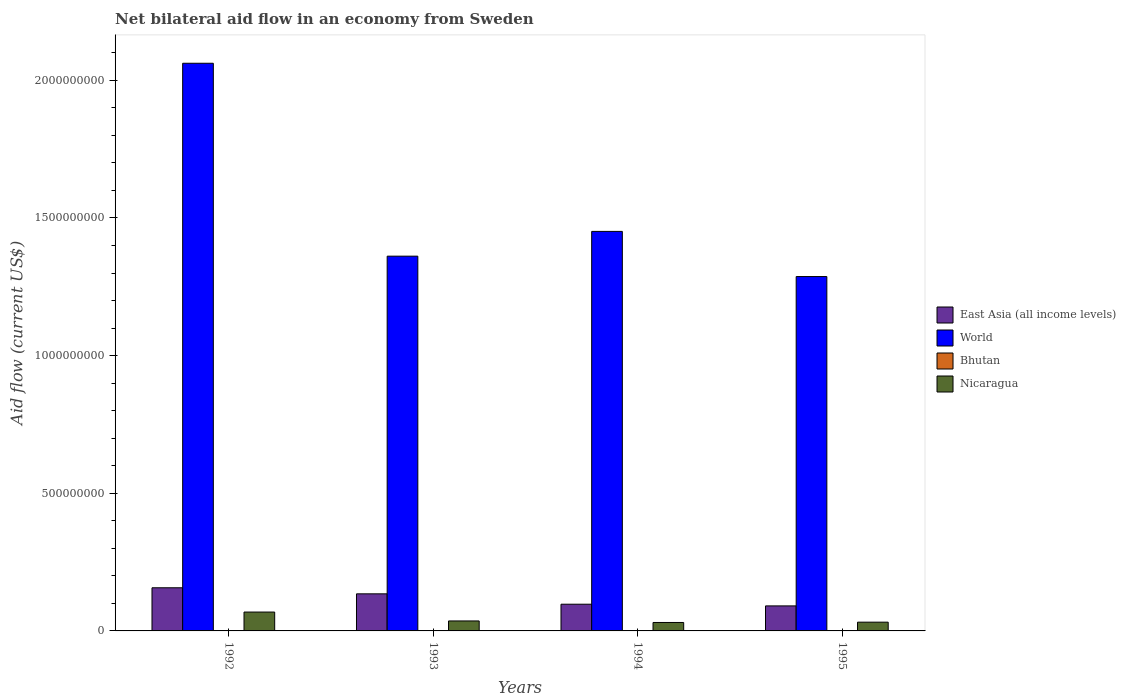How many different coloured bars are there?
Your response must be concise. 4. How many bars are there on the 4th tick from the right?
Keep it short and to the point. 4. What is the label of the 4th group of bars from the left?
Offer a terse response. 1995. In how many cases, is the number of bars for a given year not equal to the number of legend labels?
Offer a terse response. 0. What is the net bilateral aid flow in World in 1993?
Ensure brevity in your answer.  1.36e+09. Across all years, what is the maximum net bilateral aid flow in World?
Make the answer very short. 2.06e+09. Across all years, what is the minimum net bilateral aid flow in East Asia (all income levels)?
Ensure brevity in your answer.  9.09e+07. In which year was the net bilateral aid flow in Bhutan maximum?
Provide a short and direct response. 1995. What is the total net bilateral aid flow in Nicaragua in the graph?
Offer a very short reply. 1.67e+08. What is the difference between the net bilateral aid flow in Nicaragua in 1992 and that in 1994?
Keep it short and to the point. 3.79e+07. What is the difference between the net bilateral aid flow in World in 1994 and the net bilateral aid flow in Nicaragua in 1995?
Keep it short and to the point. 1.42e+09. What is the average net bilateral aid flow in Nicaragua per year?
Make the answer very short. 4.18e+07. In the year 1995, what is the difference between the net bilateral aid flow in Nicaragua and net bilateral aid flow in East Asia (all income levels)?
Give a very brief answer. -5.91e+07. In how many years, is the net bilateral aid flow in World greater than 200000000 US$?
Your response must be concise. 4. What is the ratio of the net bilateral aid flow in World in 1993 to that in 1994?
Provide a succinct answer. 0.94. Is the net bilateral aid flow in Bhutan in 1993 less than that in 1994?
Your response must be concise. Yes. Is the difference between the net bilateral aid flow in Nicaragua in 1993 and 1994 greater than the difference between the net bilateral aid flow in East Asia (all income levels) in 1993 and 1994?
Provide a short and direct response. No. What is the difference between the highest and the second highest net bilateral aid flow in World?
Your answer should be compact. 6.11e+08. Is the sum of the net bilateral aid flow in East Asia (all income levels) in 1993 and 1994 greater than the maximum net bilateral aid flow in Bhutan across all years?
Your response must be concise. Yes. What does the 3rd bar from the left in 1995 represents?
Offer a very short reply. Bhutan. Is it the case that in every year, the sum of the net bilateral aid flow in Nicaragua and net bilateral aid flow in East Asia (all income levels) is greater than the net bilateral aid flow in World?
Provide a succinct answer. No. How many years are there in the graph?
Keep it short and to the point. 4. What is the difference between two consecutive major ticks on the Y-axis?
Your answer should be compact. 5.00e+08. Are the values on the major ticks of Y-axis written in scientific E-notation?
Ensure brevity in your answer.  No. Does the graph contain any zero values?
Your answer should be very brief. No. Does the graph contain grids?
Keep it short and to the point. No. How many legend labels are there?
Your answer should be very brief. 4. What is the title of the graph?
Your answer should be compact. Net bilateral aid flow in an economy from Sweden. Does "Tunisia" appear as one of the legend labels in the graph?
Your response must be concise. No. What is the label or title of the X-axis?
Ensure brevity in your answer.  Years. What is the label or title of the Y-axis?
Provide a short and direct response. Aid flow (current US$). What is the Aid flow (current US$) of East Asia (all income levels) in 1992?
Ensure brevity in your answer.  1.57e+08. What is the Aid flow (current US$) in World in 1992?
Your answer should be compact. 2.06e+09. What is the Aid flow (current US$) in Nicaragua in 1992?
Your answer should be compact. 6.85e+07. What is the Aid flow (current US$) in East Asia (all income levels) in 1993?
Provide a short and direct response. 1.35e+08. What is the Aid flow (current US$) in World in 1993?
Offer a terse response. 1.36e+09. What is the Aid flow (current US$) in Bhutan in 1993?
Offer a terse response. 1.90e+05. What is the Aid flow (current US$) of Nicaragua in 1993?
Your response must be concise. 3.63e+07. What is the Aid flow (current US$) of East Asia (all income levels) in 1994?
Make the answer very short. 9.70e+07. What is the Aid flow (current US$) in World in 1994?
Provide a succinct answer. 1.45e+09. What is the Aid flow (current US$) in Nicaragua in 1994?
Ensure brevity in your answer.  3.07e+07. What is the Aid flow (current US$) of East Asia (all income levels) in 1995?
Provide a succinct answer. 9.09e+07. What is the Aid flow (current US$) of World in 1995?
Ensure brevity in your answer.  1.29e+09. What is the Aid flow (current US$) in Bhutan in 1995?
Provide a succinct answer. 4.80e+05. What is the Aid flow (current US$) in Nicaragua in 1995?
Keep it short and to the point. 3.18e+07. Across all years, what is the maximum Aid flow (current US$) in East Asia (all income levels)?
Provide a short and direct response. 1.57e+08. Across all years, what is the maximum Aid flow (current US$) of World?
Provide a succinct answer. 2.06e+09. Across all years, what is the maximum Aid flow (current US$) of Bhutan?
Offer a terse response. 4.80e+05. Across all years, what is the maximum Aid flow (current US$) of Nicaragua?
Your answer should be very brief. 6.85e+07. Across all years, what is the minimum Aid flow (current US$) of East Asia (all income levels)?
Offer a terse response. 9.09e+07. Across all years, what is the minimum Aid flow (current US$) of World?
Provide a short and direct response. 1.29e+09. Across all years, what is the minimum Aid flow (current US$) in Bhutan?
Give a very brief answer. 1.90e+05. Across all years, what is the minimum Aid flow (current US$) of Nicaragua?
Your answer should be compact. 3.07e+07. What is the total Aid flow (current US$) in East Asia (all income levels) in the graph?
Make the answer very short. 4.79e+08. What is the total Aid flow (current US$) in World in the graph?
Keep it short and to the point. 6.16e+09. What is the total Aid flow (current US$) of Bhutan in the graph?
Your answer should be very brief. 1.30e+06. What is the total Aid flow (current US$) in Nicaragua in the graph?
Give a very brief answer. 1.67e+08. What is the difference between the Aid flow (current US$) of East Asia (all income levels) in 1992 and that in 1993?
Your answer should be very brief. 2.20e+07. What is the difference between the Aid flow (current US$) in World in 1992 and that in 1993?
Give a very brief answer. 7.01e+08. What is the difference between the Aid flow (current US$) of Nicaragua in 1992 and that in 1993?
Provide a short and direct response. 3.23e+07. What is the difference between the Aid flow (current US$) in East Asia (all income levels) in 1992 and that in 1994?
Keep it short and to the point. 5.97e+07. What is the difference between the Aid flow (current US$) of World in 1992 and that in 1994?
Ensure brevity in your answer.  6.11e+08. What is the difference between the Aid flow (current US$) in Nicaragua in 1992 and that in 1994?
Ensure brevity in your answer.  3.79e+07. What is the difference between the Aid flow (current US$) in East Asia (all income levels) in 1992 and that in 1995?
Your answer should be compact. 6.58e+07. What is the difference between the Aid flow (current US$) of World in 1992 and that in 1995?
Make the answer very short. 7.75e+08. What is the difference between the Aid flow (current US$) in Bhutan in 1992 and that in 1995?
Make the answer very short. -1.30e+05. What is the difference between the Aid flow (current US$) of Nicaragua in 1992 and that in 1995?
Offer a terse response. 3.67e+07. What is the difference between the Aid flow (current US$) in East Asia (all income levels) in 1993 and that in 1994?
Ensure brevity in your answer.  3.77e+07. What is the difference between the Aid flow (current US$) of World in 1993 and that in 1994?
Offer a terse response. -9.00e+07. What is the difference between the Aid flow (current US$) of Nicaragua in 1993 and that in 1994?
Give a very brief answer. 5.60e+06. What is the difference between the Aid flow (current US$) in East Asia (all income levels) in 1993 and that in 1995?
Your response must be concise. 4.38e+07. What is the difference between the Aid flow (current US$) in World in 1993 and that in 1995?
Your answer should be very brief. 7.41e+07. What is the difference between the Aid flow (current US$) in Nicaragua in 1993 and that in 1995?
Offer a very short reply. 4.44e+06. What is the difference between the Aid flow (current US$) of East Asia (all income levels) in 1994 and that in 1995?
Offer a very short reply. 6.15e+06. What is the difference between the Aid flow (current US$) of World in 1994 and that in 1995?
Offer a very short reply. 1.64e+08. What is the difference between the Aid flow (current US$) in Bhutan in 1994 and that in 1995?
Your answer should be very brief. -2.00e+05. What is the difference between the Aid flow (current US$) in Nicaragua in 1994 and that in 1995?
Ensure brevity in your answer.  -1.16e+06. What is the difference between the Aid flow (current US$) of East Asia (all income levels) in 1992 and the Aid flow (current US$) of World in 1993?
Ensure brevity in your answer.  -1.20e+09. What is the difference between the Aid flow (current US$) of East Asia (all income levels) in 1992 and the Aid flow (current US$) of Bhutan in 1993?
Ensure brevity in your answer.  1.57e+08. What is the difference between the Aid flow (current US$) of East Asia (all income levels) in 1992 and the Aid flow (current US$) of Nicaragua in 1993?
Provide a short and direct response. 1.20e+08. What is the difference between the Aid flow (current US$) in World in 1992 and the Aid flow (current US$) in Bhutan in 1993?
Give a very brief answer. 2.06e+09. What is the difference between the Aid flow (current US$) in World in 1992 and the Aid flow (current US$) in Nicaragua in 1993?
Offer a terse response. 2.03e+09. What is the difference between the Aid flow (current US$) in Bhutan in 1992 and the Aid flow (current US$) in Nicaragua in 1993?
Offer a very short reply. -3.59e+07. What is the difference between the Aid flow (current US$) in East Asia (all income levels) in 1992 and the Aid flow (current US$) in World in 1994?
Offer a very short reply. -1.29e+09. What is the difference between the Aid flow (current US$) of East Asia (all income levels) in 1992 and the Aid flow (current US$) of Bhutan in 1994?
Ensure brevity in your answer.  1.56e+08. What is the difference between the Aid flow (current US$) of East Asia (all income levels) in 1992 and the Aid flow (current US$) of Nicaragua in 1994?
Provide a succinct answer. 1.26e+08. What is the difference between the Aid flow (current US$) in World in 1992 and the Aid flow (current US$) in Bhutan in 1994?
Offer a very short reply. 2.06e+09. What is the difference between the Aid flow (current US$) in World in 1992 and the Aid flow (current US$) in Nicaragua in 1994?
Make the answer very short. 2.03e+09. What is the difference between the Aid flow (current US$) in Bhutan in 1992 and the Aid flow (current US$) in Nicaragua in 1994?
Keep it short and to the point. -3.03e+07. What is the difference between the Aid flow (current US$) of East Asia (all income levels) in 1992 and the Aid flow (current US$) of World in 1995?
Give a very brief answer. -1.13e+09. What is the difference between the Aid flow (current US$) in East Asia (all income levels) in 1992 and the Aid flow (current US$) in Bhutan in 1995?
Your answer should be very brief. 1.56e+08. What is the difference between the Aid flow (current US$) of East Asia (all income levels) in 1992 and the Aid flow (current US$) of Nicaragua in 1995?
Keep it short and to the point. 1.25e+08. What is the difference between the Aid flow (current US$) in World in 1992 and the Aid flow (current US$) in Bhutan in 1995?
Ensure brevity in your answer.  2.06e+09. What is the difference between the Aid flow (current US$) in World in 1992 and the Aid flow (current US$) in Nicaragua in 1995?
Keep it short and to the point. 2.03e+09. What is the difference between the Aid flow (current US$) of Bhutan in 1992 and the Aid flow (current US$) of Nicaragua in 1995?
Keep it short and to the point. -3.15e+07. What is the difference between the Aid flow (current US$) in East Asia (all income levels) in 1993 and the Aid flow (current US$) in World in 1994?
Keep it short and to the point. -1.32e+09. What is the difference between the Aid flow (current US$) of East Asia (all income levels) in 1993 and the Aid flow (current US$) of Bhutan in 1994?
Keep it short and to the point. 1.34e+08. What is the difference between the Aid flow (current US$) in East Asia (all income levels) in 1993 and the Aid flow (current US$) in Nicaragua in 1994?
Give a very brief answer. 1.04e+08. What is the difference between the Aid flow (current US$) of World in 1993 and the Aid flow (current US$) of Bhutan in 1994?
Offer a very short reply. 1.36e+09. What is the difference between the Aid flow (current US$) in World in 1993 and the Aid flow (current US$) in Nicaragua in 1994?
Offer a terse response. 1.33e+09. What is the difference between the Aid flow (current US$) of Bhutan in 1993 and the Aid flow (current US$) of Nicaragua in 1994?
Give a very brief answer. -3.05e+07. What is the difference between the Aid flow (current US$) in East Asia (all income levels) in 1993 and the Aid flow (current US$) in World in 1995?
Your answer should be compact. -1.15e+09. What is the difference between the Aid flow (current US$) of East Asia (all income levels) in 1993 and the Aid flow (current US$) of Bhutan in 1995?
Offer a very short reply. 1.34e+08. What is the difference between the Aid flow (current US$) of East Asia (all income levels) in 1993 and the Aid flow (current US$) of Nicaragua in 1995?
Your answer should be compact. 1.03e+08. What is the difference between the Aid flow (current US$) in World in 1993 and the Aid flow (current US$) in Bhutan in 1995?
Your response must be concise. 1.36e+09. What is the difference between the Aid flow (current US$) in World in 1993 and the Aid flow (current US$) in Nicaragua in 1995?
Your answer should be very brief. 1.33e+09. What is the difference between the Aid flow (current US$) in Bhutan in 1993 and the Aid flow (current US$) in Nicaragua in 1995?
Ensure brevity in your answer.  -3.16e+07. What is the difference between the Aid flow (current US$) in East Asia (all income levels) in 1994 and the Aid flow (current US$) in World in 1995?
Offer a very short reply. -1.19e+09. What is the difference between the Aid flow (current US$) in East Asia (all income levels) in 1994 and the Aid flow (current US$) in Bhutan in 1995?
Your answer should be very brief. 9.66e+07. What is the difference between the Aid flow (current US$) of East Asia (all income levels) in 1994 and the Aid flow (current US$) of Nicaragua in 1995?
Your answer should be compact. 6.52e+07. What is the difference between the Aid flow (current US$) in World in 1994 and the Aid flow (current US$) in Bhutan in 1995?
Ensure brevity in your answer.  1.45e+09. What is the difference between the Aid flow (current US$) in World in 1994 and the Aid flow (current US$) in Nicaragua in 1995?
Provide a succinct answer. 1.42e+09. What is the difference between the Aid flow (current US$) of Bhutan in 1994 and the Aid flow (current US$) of Nicaragua in 1995?
Make the answer very short. -3.15e+07. What is the average Aid flow (current US$) in East Asia (all income levels) per year?
Keep it short and to the point. 1.20e+08. What is the average Aid flow (current US$) of World per year?
Your answer should be compact. 1.54e+09. What is the average Aid flow (current US$) of Bhutan per year?
Offer a terse response. 3.25e+05. What is the average Aid flow (current US$) in Nicaragua per year?
Offer a terse response. 4.18e+07. In the year 1992, what is the difference between the Aid flow (current US$) of East Asia (all income levels) and Aid flow (current US$) of World?
Make the answer very short. -1.91e+09. In the year 1992, what is the difference between the Aid flow (current US$) in East Asia (all income levels) and Aid flow (current US$) in Bhutan?
Your response must be concise. 1.56e+08. In the year 1992, what is the difference between the Aid flow (current US$) in East Asia (all income levels) and Aid flow (current US$) in Nicaragua?
Provide a short and direct response. 8.82e+07. In the year 1992, what is the difference between the Aid flow (current US$) of World and Aid flow (current US$) of Bhutan?
Provide a short and direct response. 2.06e+09. In the year 1992, what is the difference between the Aid flow (current US$) of World and Aid flow (current US$) of Nicaragua?
Give a very brief answer. 1.99e+09. In the year 1992, what is the difference between the Aid flow (current US$) in Bhutan and Aid flow (current US$) in Nicaragua?
Your response must be concise. -6.82e+07. In the year 1993, what is the difference between the Aid flow (current US$) of East Asia (all income levels) and Aid flow (current US$) of World?
Your answer should be very brief. -1.23e+09. In the year 1993, what is the difference between the Aid flow (current US$) of East Asia (all income levels) and Aid flow (current US$) of Bhutan?
Provide a short and direct response. 1.35e+08. In the year 1993, what is the difference between the Aid flow (current US$) in East Asia (all income levels) and Aid flow (current US$) in Nicaragua?
Your answer should be very brief. 9.84e+07. In the year 1993, what is the difference between the Aid flow (current US$) in World and Aid flow (current US$) in Bhutan?
Your answer should be compact. 1.36e+09. In the year 1993, what is the difference between the Aid flow (current US$) in World and Aid flow (current US$) in Nicaragua?
Offer a terse response. 1.33e+09. In the year 1993, what is the difference between the Aid flow (current US$) in Bhutan and Aid flow (current US$) in Nicaragua?
Ensure brevity in your answer.  -3.61e+07. In the year 1994, what is the difference between the Aid flow (current US$) in East Asia (all income levels) and Aid flow (current US$) in World?
Provide a short and direct response. -1.35e+09. In the year 1994, what is the difference between the Aid flow (current US$) of East Asia (all income levels) and Aid flow (current US$) of Bhutan?
Your response must be concise. 9.68e+07. In the year 1994, what is the difference between the Aid flow (current US$) in East Asia (all income levels) and Aid flow (current US$) in Nicaragua?
Offer a terse response. 6.64e+07. In the year 1994, what is the difference between the Aid flow (current US$) in World and Aid flow (current US$) in Bhutan?
Offer a very short reply. 1.45e+09. In the year 1994, what is the difference between the Aid flow (current US$) in World and Aid flow (current US$) in Nicaragua?
Your response must be concise. 1.42e+09. In the year 1994, what is the difference between the Aid flow (current US$) in Bhutan and Aid flow (current US$) in Nicaragua?
Your answer should be compact. -3.04e+07. In the year 1995, what is the difference between the Aid flow (current US$) in East Asia (all income levels) and Aid flow (current US$) in World?
Offer a very short reply. -1.20e+09. In the year 1995, what is the difference between the Aid flow (current US$) in East Asia (all income levels) and Aid flow (current US$) in Bhutan?
Offer a terse response. 9.04e+07. In the year 1995, what is the difference between the Aid flow (current US$) of East Asia (all income levels) and Aid flow (current US$) of Nicaragua?
Ensure brevity in your answer.  5.91e+07. In the year 1995, what is the difference between the Aid flow (current US$) of World and Aid flow (current US$) of Bhutan?
Provide a succinct answer. 1.29e+09. In the year 1995, what is the difference between the Aid flow (current US$) of World and Aid flow (current US$) of Nicaragua?
Your response must be concise. 1.26e+09. In the year 1995, what is the difference between the Aid flow (current US$) in Bhutan and Aid flow (current US$) in Nicaragua?
Ensure brevity in your answer.  -3.13e+07. What is the ratio of the Aid flow (current US$) of East Asia (all income levels) in 1992 to that in 1993?
Give a very brief answer. 1.16. What is the ratio of the Aid flow (current US$) of World in 1992 to that in 1993?
Provide a short and direct response. 1.51. What is the ratio of the Aid flow (current US$) of Bhutan in 1992 to that in 1993?
Your answer should be very brief. 1.84. What is the ratio of the Aid flow (current US$) of Nicaragua in 1992 to that in 1993?
Your response must be concise. 1.89. What is the ratio of the Aid flow (current US$) of East Asia (all income levels) in 1992 to that in 1994?
Your answer should be very brief. 1.62. What is the ratio of the Aid flow (current US$) in World in 1992 to that in 1994?
Your response must be concise. 1.42. What is the ratio of the Aid flow (current US$) of Nicaragua in 1992 to that in 1994?
Provide a succinct answer. 2.23. What is the ratio of the Aid flow (current US$) of East Asia (all income levels) in 1992 to that in 1995?
Give a very brief answer. 1.72. What is the ratio of the Aid flow (current US$) of World in 1992 to that in 1995?
Provide a succinct answer. 1.6. What is the ratio of the Aid flow (current US$) in Bhutan in 1992 to that in 1995?
Provide a short and direct response. 0.73. What is the ratio of the Aid flow (current US$) of Nicaragua in 1992 to that in 1995?
Provide a short and direct response. 2.15. What is the ratio of the Aid flow (current US$) in East Asia (all income levels) in 1993 to that in 1994?
Give a very brief answer. 1.39. What is the ratio of the Aid flow (current US$) in World in 1993 to that in 1994?
Your answer should be compact. 0.94. What is the ratio of the Aid flow (current US$) in Bhutan in 1993 to that in 1994?
Your response must be concise. 0.68. What is the ratio of the Aid flow (current US$) of Nicaragua in 1993 to that in 1994?
Make the answer very short. 1.18. What is the ratio of the Aid flow (current US$) in East Asia (all income levels) in 1993 to that in 1995?
Provide a short and direct response. 1.48. What is the ratio of the Aid flow (current US$) in World in 1993 to that in 1995?
Provide a short and direct response. 1.06. What is the ratio of the Aid flow (current US$) in Bhutan in 1993 to that in 1995?
Offer a very short reply. 0.4. What is the ratio of the Aid flow (current US$) in Nicaragua in 1993 to that in 1995?
Provide a succinct answer. 1.14. What is the ratio of the Aid flow (current US$) of East Asia (all income levels) in 1994 to that in 1995?
Your response must be concise. 1.07. What is the ratio of the Aid flow (current US$) of World in 1994 to that in 1995?
Provide a succinct answer. 1.13. What is the ratio of the Aid flow (current US$) of Bhutan in 1994 to that in 1995?
Make the answer very short. 0.58. What is the ratio of the Aid flow (current US$) of Nicaragua in 1994 to that in 1995?
Make the answer very short. 0.96. What is the difference between the highest and the second highest Aid flow (current US$) of East Asia (all income levels)?
Make the answer very short. 2.20e+07. What is the difference between the highest and the second highest Aid flow (current US$) of World?
Make the answer very short. 6.11e+08. What is the difference between the highest and the second highest Aid flow (current US$) in Bhutan?
Ensure brevity in your answer.  1.30e+05. What is the difference between the highest and the second highest Aid flow (current US$) in Nicaragua?
Your answer should be very brief. 3.23e+07. What is the difference between the highest and the lowest Aid flow (current US$) in East Asia (all income levels)?
Your answer should be compact. 6.58e+07. What is the difference between the highest and the lowest Aid flow (current US$) in World?
Your answer should be very brief. 7.75e+08. What is the difference between the highest and the lowest Aid flow (current US$) in Nicaragua?
Keep it short and to the point. 3.79e+07. 